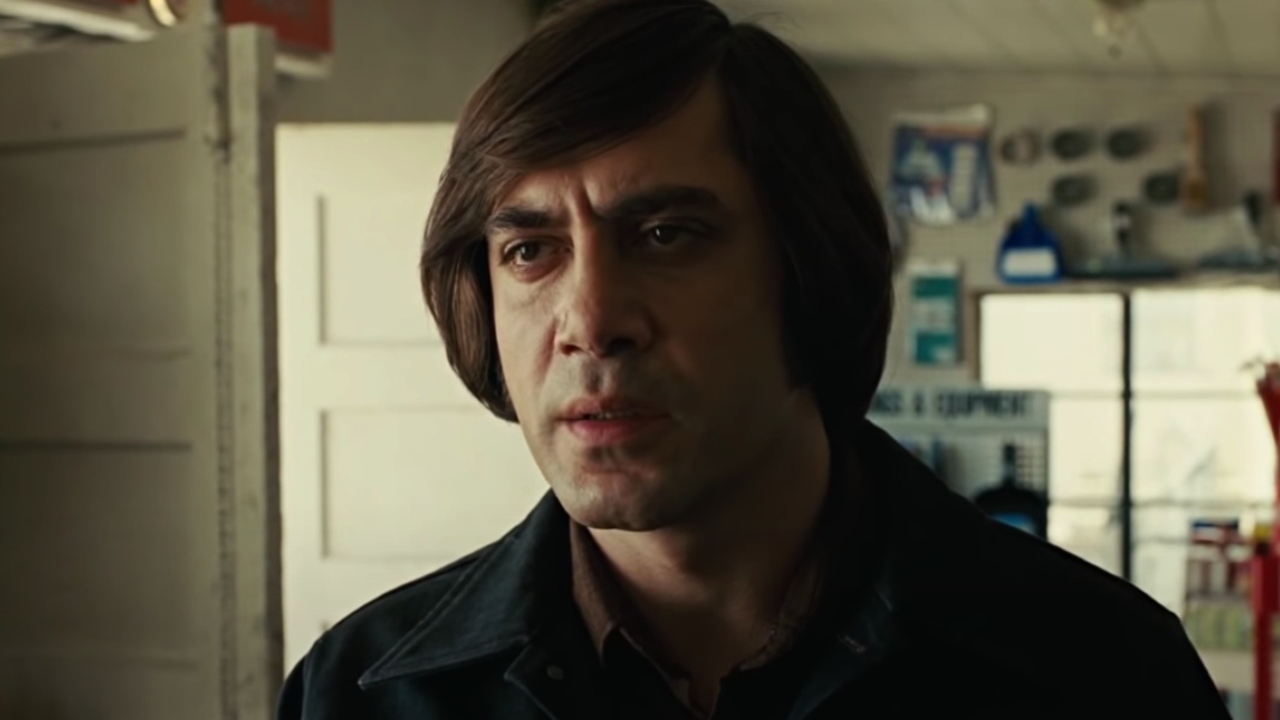Describe the character's potential backstory. The character in the image could be a skilled craftsman, perhaps working in an automotive shop. With a background in mechanics, he might be facing a dilemma about completing a risky job that goes beyond standard repairs. His serious expression hints at a deeper story involving past hardships, possibly dealing with personal losses or unfulfilled dreams. The tools in the background symbolize his dedication to his craft, even as he grapples with the challenges fate has thrown his way. What might have led him to this moment of deep thought? Several scenarios could have led to this moment. Perhaps he recently received news about a close friend's accident that requires his unique skills to fix a life-saving machine. Alternatively, he might be in the middle of contemplating a life-changing decision, such as closing his long-running shop due to financial pressures. The tools surrounding him serve as silent witnesses to his inner conflict, underscoring the gravity of the decision he faces. Can you describe a casual day in his life? On a typical day, he might wake up early and head to his workshop, sipping a strong cup of coffee as he checks his schedule. He would spend most of his time meticulously working on various machinery, occasionally stepping out to help a customer or order parts. At lunchtime, he might grab a simple meal from a nearby diner, exchanging a few words with the regulars. Evenings would find him finishing up his work, reviewing the day's progress, and planning for tomorrow. Such a routine provides him with both comfort and a way to keep his mind occupied. 